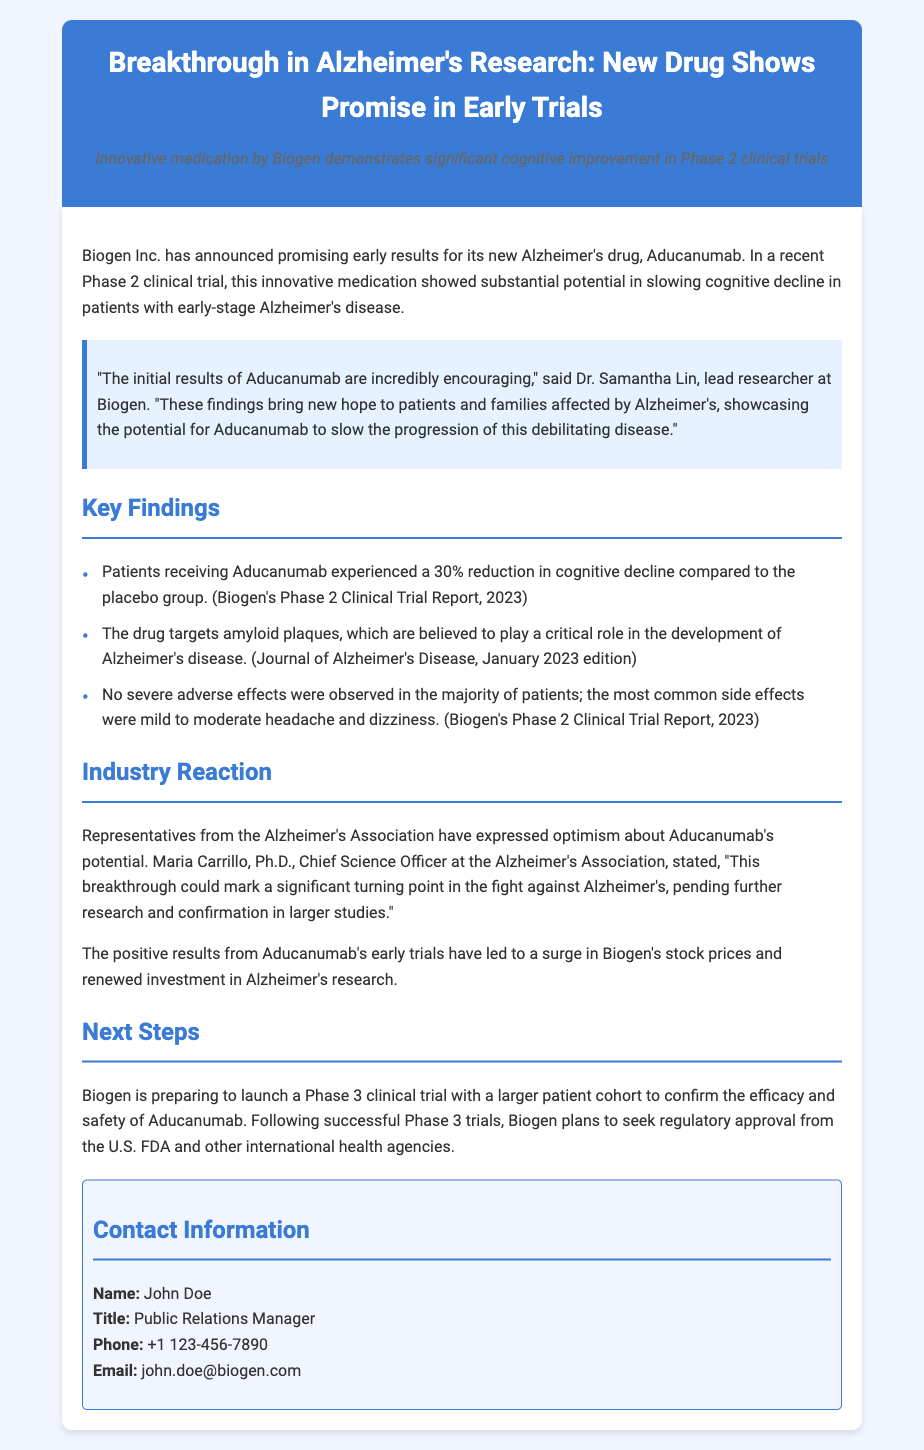What is the name of the new Alzheimer's drug? The document states that the new drug is called Aducanumab.
Answer: Aducanumab Who is the lead researcher at Biogen? According to the document, Dr. Samantha Lin is the lead researcher at Biogen.
Answer: Dr. Samantha Lin What percentage reduction in cognitive decline did patients experience? The document mentions a 30% reduction in cognitive decline for patients receiving Aducanumab compared to the placebo group.
Answer: 30% What are the most common side effects observed? The common side effects listed in the document are mild to moderate headache and dizziness.
Answer: Headache and dizziness What is the next step for Biogen after the Phase 2 trial? The document states that Biogen is preparing to launch a Phase 3 clinical trial with a larger patient cohort.
Answer: Phase 3 clinical trial What organization expressed optimism about Aducanumab's potential? The document notes that the Alzheimer's Association expressed optimism regarding Aducanumab's potential.
Answer: Alzheimer's Association Who is the Chief Science Officer at the Alzheimer's Association? The document mentions Maria Carrillo as the Chief Science Officer at the Alzheimer's Association.
Answer: Maria Carrillo What impact did the early trial results have on Biogen's stock? The document notes a surge in Biogen's stock prices following the positive results from the early trials.
Answer: Surge in stock prices 